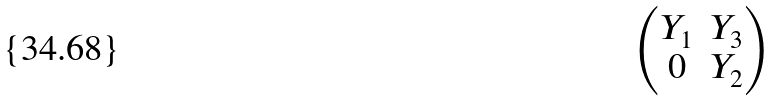<formula> <loc_0><loc_0><loc_500><loc_500>\begin{pmatrix} Y _ { 1 } & Y _ { 3 } \\ 0 & Y _ { 2 } \end{pmatrix}</formula> 